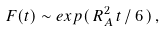Convert formula to latex. <formula><loc_0><loc_0><loc_500><loc_500>F ( t ) \sim e x p ( \, R _ { A } ^ { 2 } \, t \, / \, 6 \, ) \, ,</formula> 